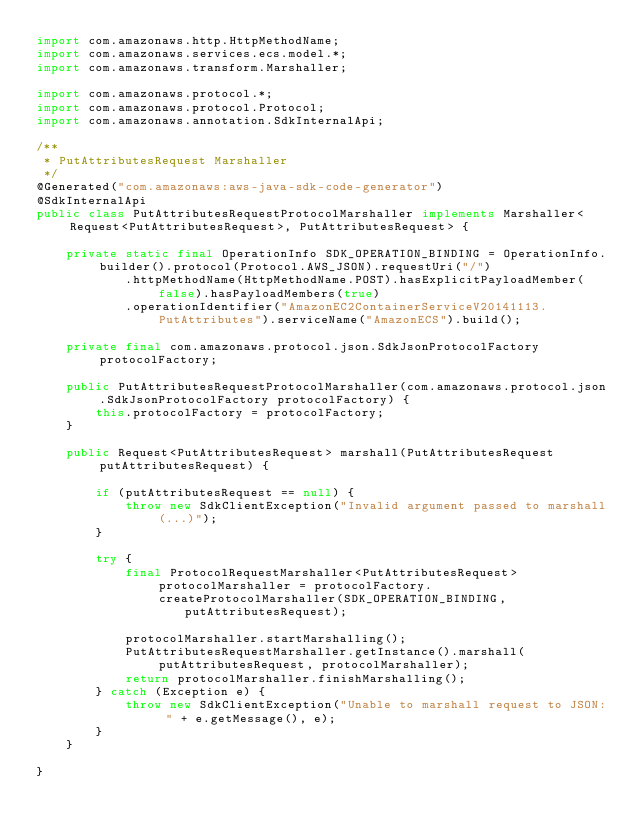Convert code to text. <code><loc_0><loc_0><loc_500><loc_500><_Java_>import com.amazonaws.http.HttpMethodName;
import com.amazonaws.services.ecs.model.*;
import com.amazonaws.transform.Marshaller;

import com.amazonaws.protocol.*;
import com.amazonaws.protocol.Protocol;
import com.amazonaws.annotation.SdkInternalApi;

/**
 * PutAttributesRequest Marshaller
 */
@Generated("com.amazonaws:aws-java-sdk-code-generator")
@SdkInternalApi
public class PutAttributesRequestProtocolMarshaller implements Marshaller<Request<PutAttributesRequest>, PutAttributesRequest> {

    private static final OperationInfo SDK_OPERATION_BINDING = OperationInfo.builder().protocol(Protocol.AWS_JSON).requestUri("/")
            .httpMethodName(HttpMethodName.POST).hasExplicitPayloadMember(false).hasPayloadMembers(true)
            .operationIdentifier("AmazonEC2ContainerServiceV20141113.PutAttributes").serviceName("AmazonECS").build();

    private final com.amazonaws.protocol.json.SdkJsonProtocolFactory protocolFactory;

    public PutAttributesRequestProtocolMarshaller(com.amazonaws.protocol.json.SdkJsonProtocolFactory protocolFactory) {
        this.protocolFactory = protocolFactory;
    }

    public Request<PutAttributesRequest> marshall(PutAttributesRequest putAttributesRequest) {

        if (putAttributesRequest == null) {
            throw new SdkClientException("Invalid argument passed to marshall(...)");
        }

        try {
            final ProtocolRequestMarshaller<PutAttributesRequest> protocolMarshaller = protocolFactory.createProtocolMarshaller(SDK_OPERATION_BINDING,
                    putAttributesRequest);

            protocolMarshaller.startMarshalling();
            PutAttributesRequestMarshaller.getInstance().marshall(putAttributesRequest, protocolMarshaller);
            return protocolMarshaller.finishMarshalling();
        } catch (Exception e) {
            throw new SdkClientException("Unable to marshall request to JSON: " + e.getMessage(), e);
        }
    }

}
</code> 